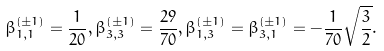<formula> <loc_0><loc_0><loc_500><loc_500>\beta _ { 1 , 1 } ^ { \left ( \pm 1 \right ) } = \frac { 1 } { 2 0 } , \beta _ { 3 , 3 } ^ { \left ( \pm 1 \right ) } = \frac { 2 9 } { 7 0 } , \beta _ { 1 , 3 } ^ { \left ( \pm 1 \right ) } = \beta _ { 3 , 1 } ^ { \left ( \pm 1 \right ) } = - \frac { 1 } { 7 0 } \sqrt { \frac { 3 } { 2 } } .</formula> 